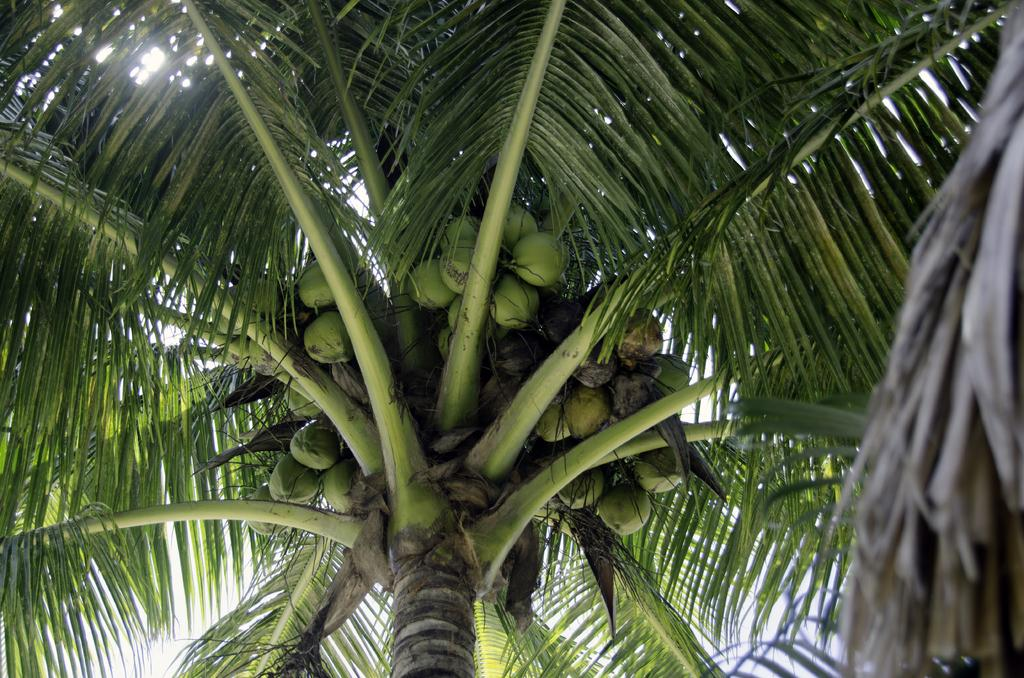What type of fruit can be seen in the image? There are coconuts in the image. What type of tree is associated with the coconuts in the image? There is a coconut tree in the image. Reasoning: Let's think step by step by step in order to produce the conversation. We start by identifying the main subject in the image, which is the coconuts. Then, we expand the conversation to include the tree associated with the coconuts, providing more context about the image. Each question is designed to elicit a specific detail about the image that is known from the provided facts. Absurd Question/Answer: What type of liquid is being poured from the coconuts in the image? There is no liquid being poured from the coconuts in the image; the coconuts are simply visible on the tree. What type of metal is present in the image? There is no metal, such as zinc, present in the image; it features coconuts and a coconut tree. 